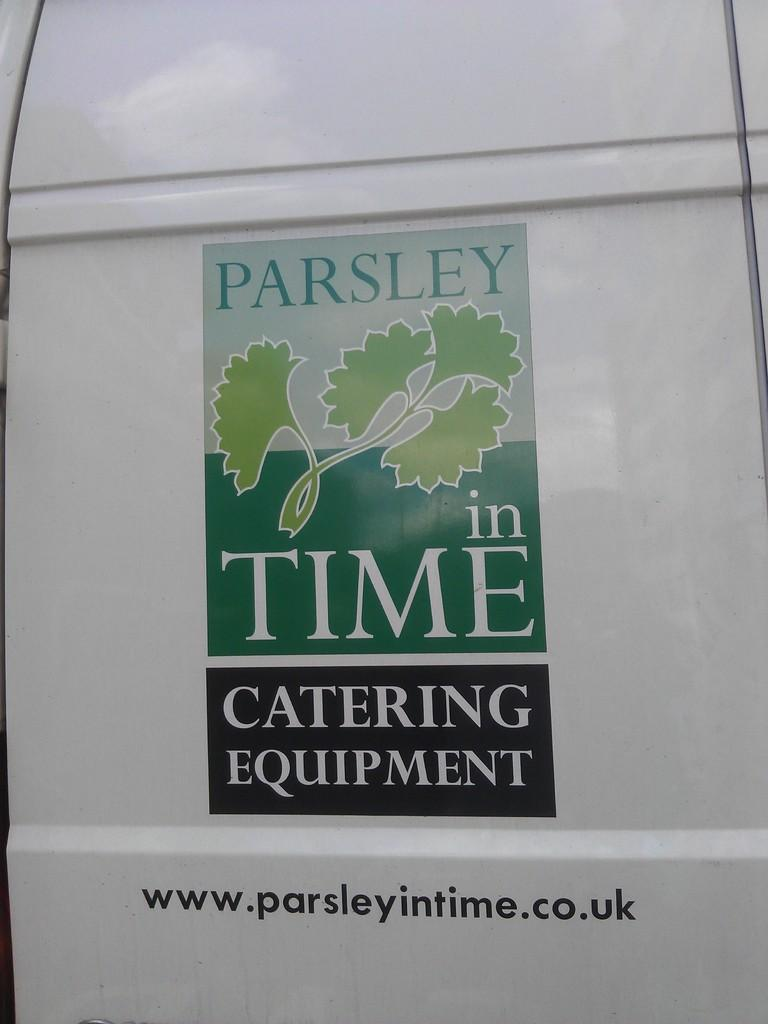What is featured on the vehicle in the image? There is a logo on a vehicle in the image. What type of soap is being used to clean the quartz in the image? There is no soap or quartz present in the image; it only features a logo on a vehicle. 